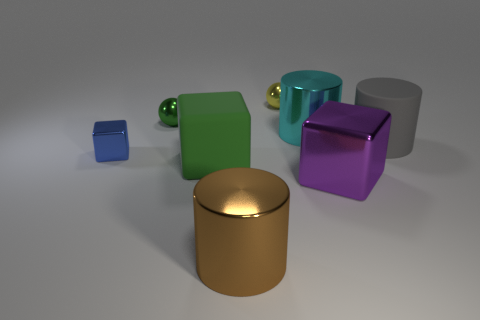Add 1 cyan shiny cylinders. How many objects exist? 9 Subtract all large metallic cubes. How many cubes are left? 2 Subtract all spheres. How many objects are left? 6 Subtract 2 balls. How many balls are left? 0 Subtract all cyan cubes. Subtract all blue cylinders. How many cubes are left? 3 Subtract all brown cylinders. How many green spheres are left? 1 Subtract all large purple metallic cylinders. Subtract all purple metal objects. How many objects are left? 7 Add 1 big gray matte things. How many big gray matte things are left? 2 Add 1 large cyan cylinders. How many large cyan cylinders exist? 2 Subtract all green cubes. How many cubes are left? 2 